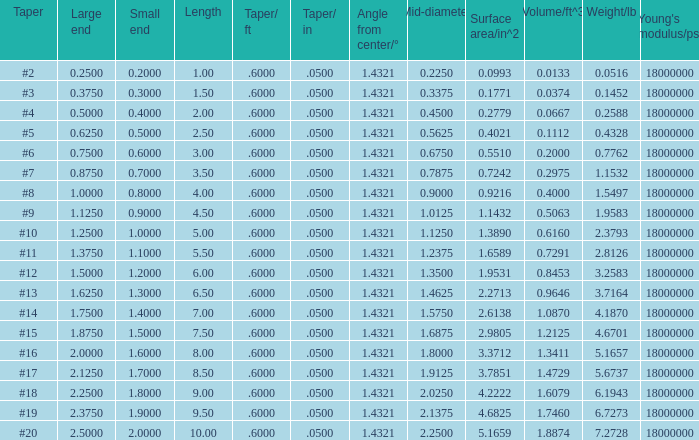Which Taper/ft that has a Large end smaller than 0.5, and a Taper of #2? 0.6. 